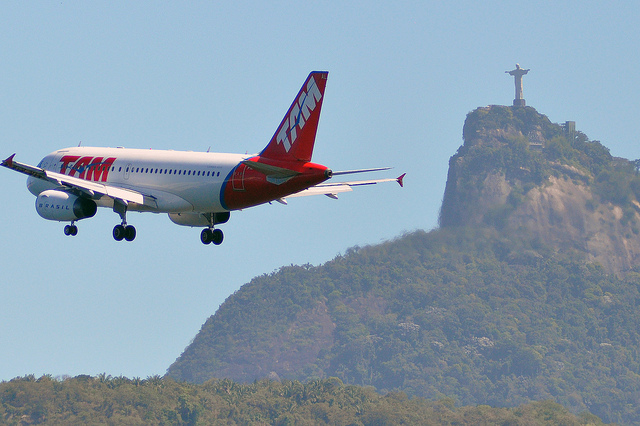<image>What religious figure is the subject of the sculpture on the top of the hill? I am not sure about the religious figure of the sculpture on the top of the hill. It can be Jesus or St Christopher. What religious figure is the subject of the sculpture on the top of the hill? I am not sure which religious figure is the subject of the sculpture on the top of the hill. It can be St. Christopher, Jesus or God. 